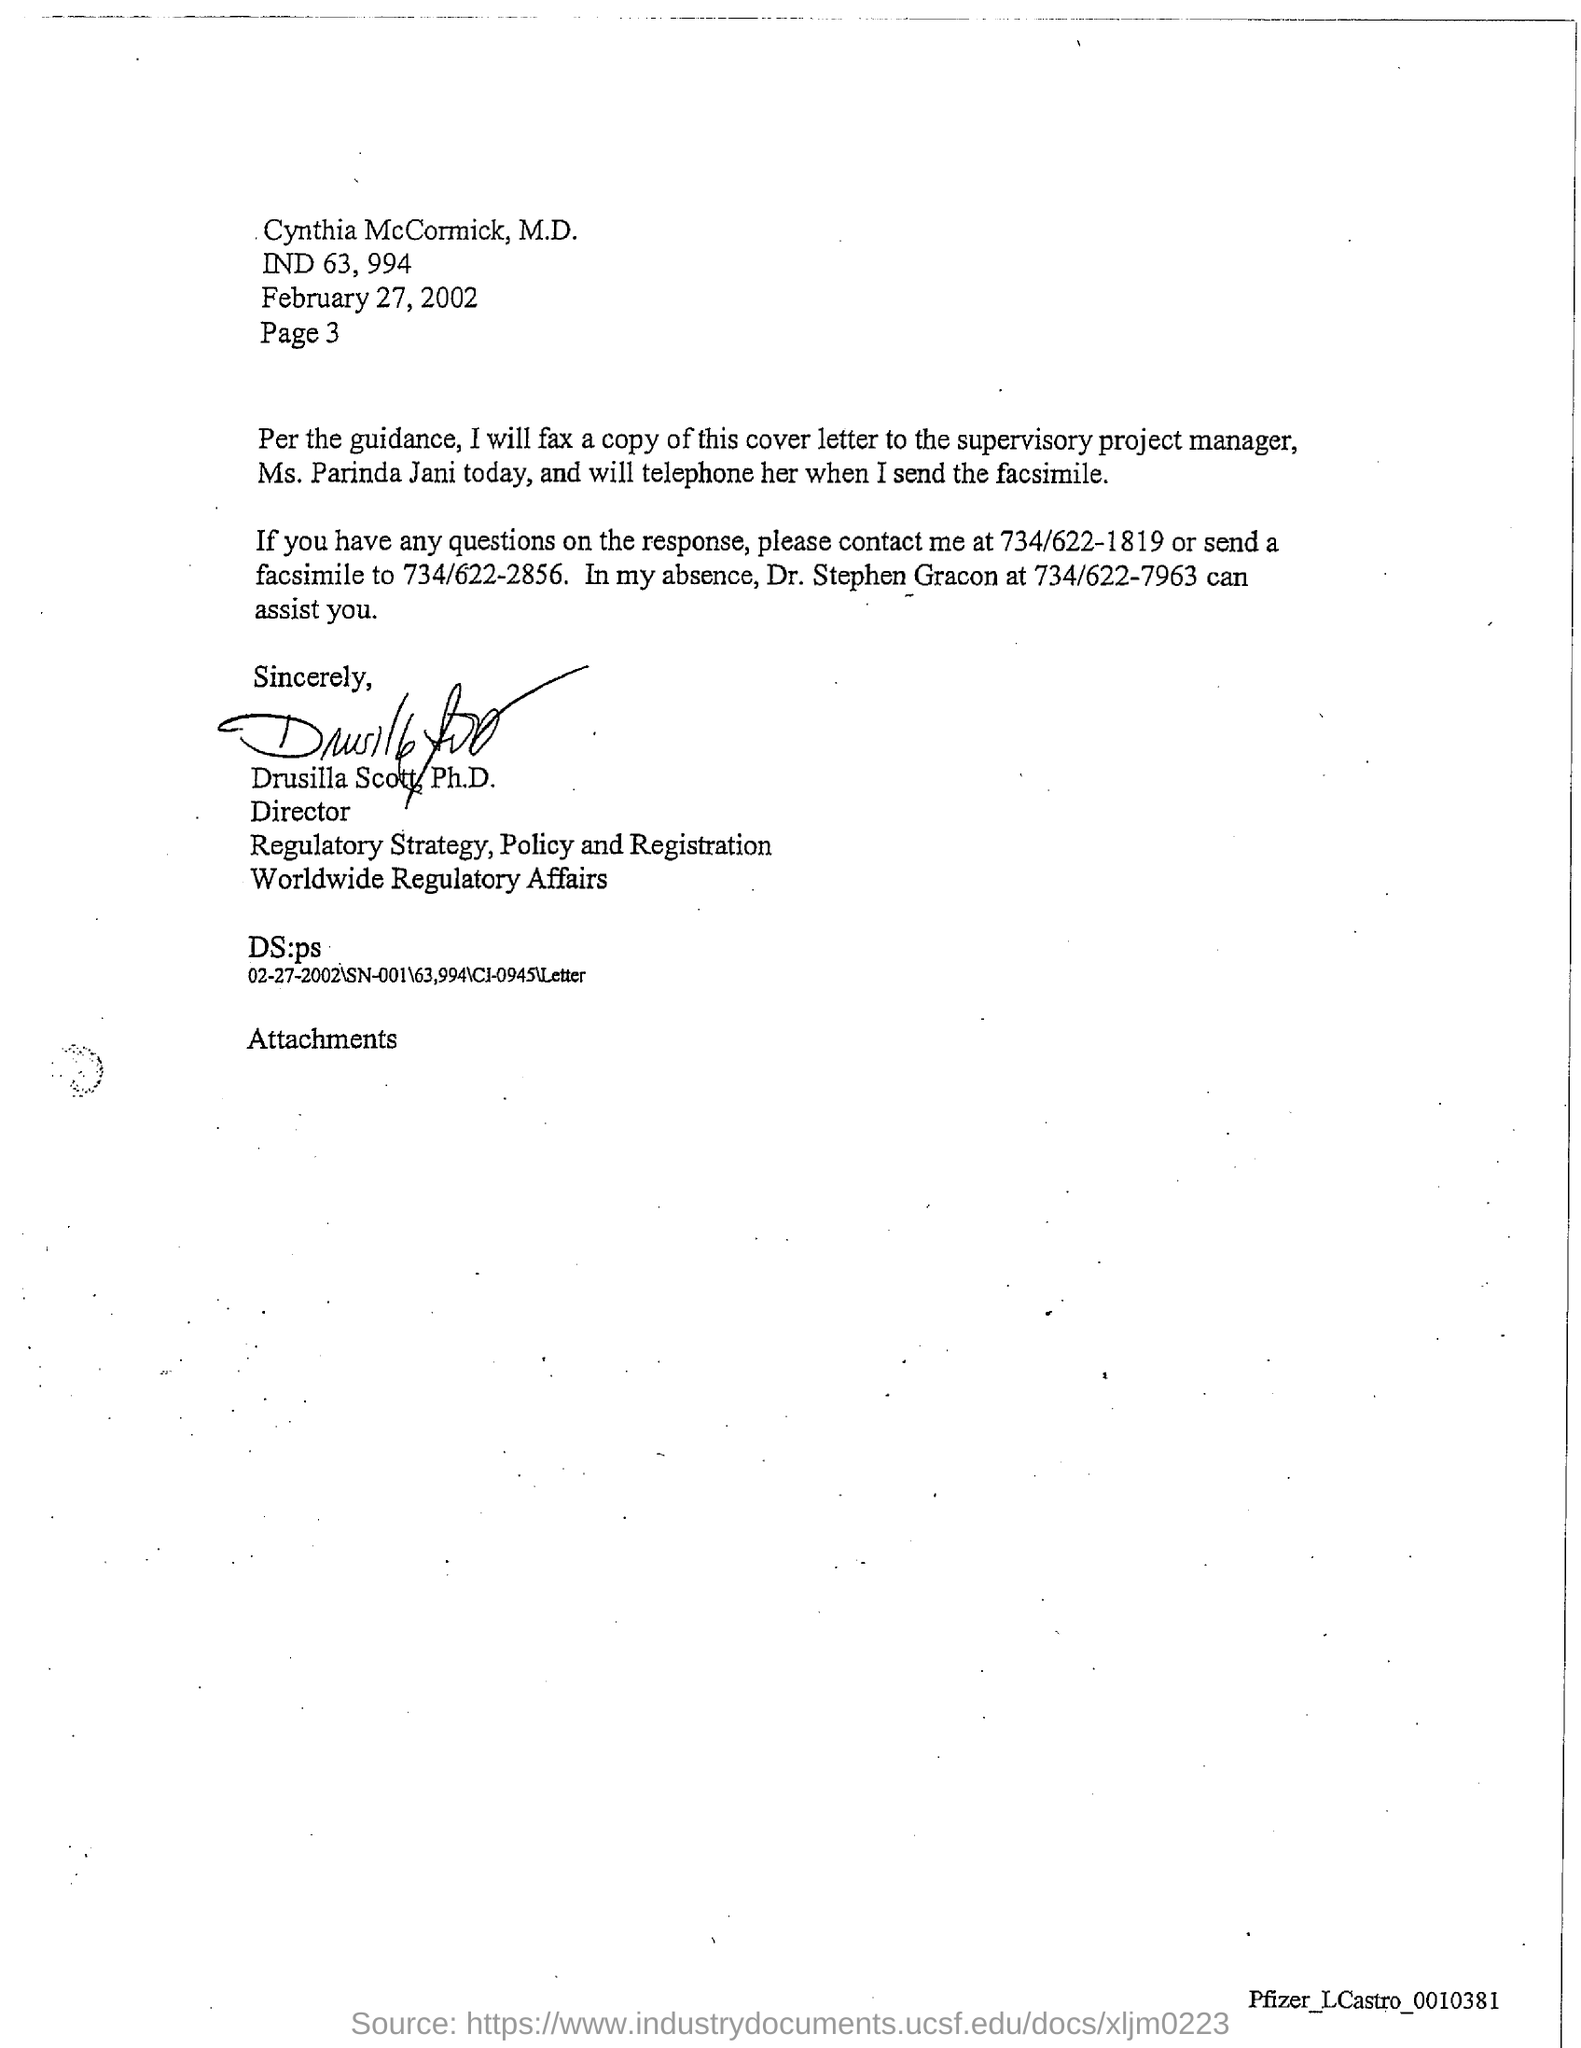What is the date mentioned in this letter?
Ensure brevity in your answer.  February 27, 2002. What is the page no mentioned in this letter?
Give a very brief answer. Page 3. Who has signed this letter?
Provide a succinct answer. Drusilla Scott, Ph.D. What is the contact no of Dr. Stephen Gracon mentioned in the letter?
Keep it short and to the point. 734/622-7963. Who is the addressee of this letter?
Make the answer very short. Cynthia McCormick, M.D. 